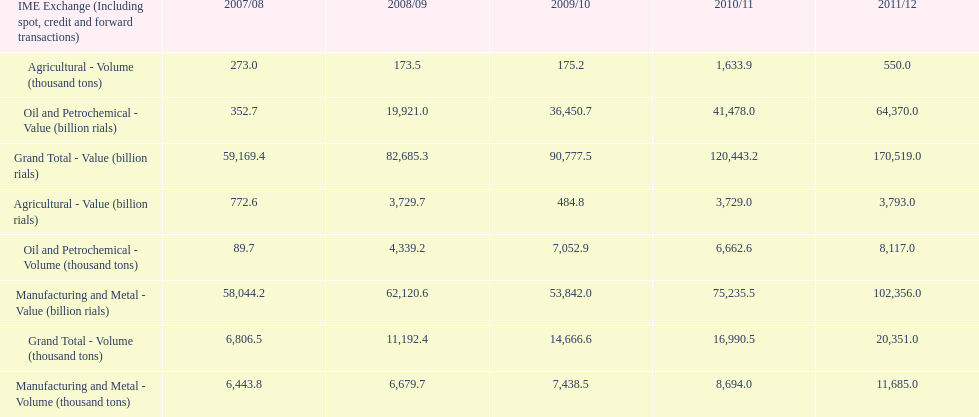How many consecutive year did the grand total value grow in iran? 4. 